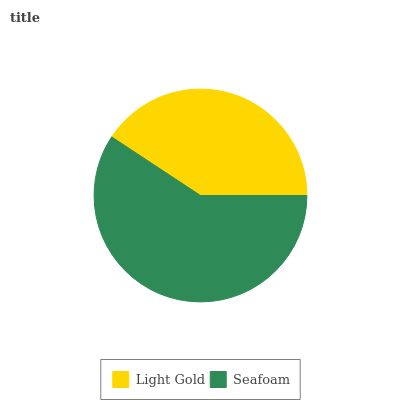Is Light Gold the minimum?
Answer yes or no. Yes. Is Seafoam the maximum?
Answer yes or no. Yes. Is Seafoam the minimum?
Answer yes or no. No. Is Seafoam greater than Light Gold?
Answer yes or no. Yes. Is Light Gold less than Seafoam?
Answer yes or no. Yes. Is Light Gold greater than Seafoam?
Answer yes or no. No. Is Seafoam less than Light Gold?
Answer yes or no. No. Is Seafoam the high median?
Answer yes or no. Yes. Is Light Gold the low median?
Answer yes or no. Yes. Is Light Gold the high median?
Answer yes or no. No. Is Seafoam the low median?
Answer yes or no. No. 